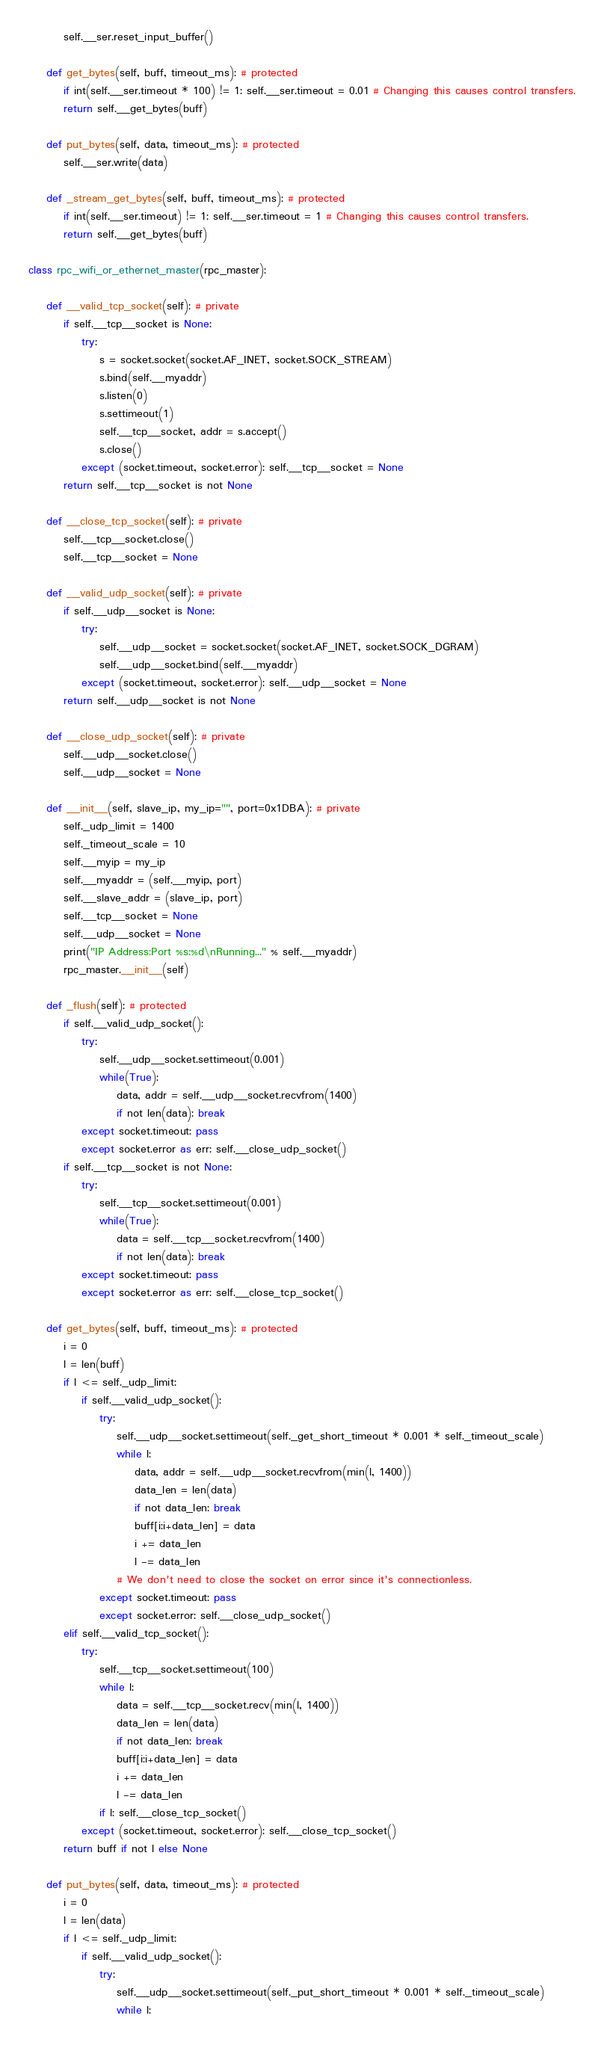<code> <loc_0><loc_0><loc_500><loc_500><_Python_>        self.__ser.reset_input_buffer()

    def get_bytes(self, buff, timeout_ms): # protected
        if int(self.__ser.timeout * 100) != 1: self.__ser.timeout = 0.01 # Changing this causes control transfers.
        return self.__get_bytes(buff)

    def put_bytes(self, data, timeout_ms): # protected
        self.__ser.write(data)

    def _stream_get_bytes(self, buff, timeout_ms): # protected
        if int(self.__ser.timeout) != 1: self.__ser.timeout = 1 # Changing this causes control transfers.
        return self.__get_bytes(buff)

class rpc_wifi_or_ethernet_master(rpc_master):

    def __valid_tcp_socket(self): # private
        if self.__tcp__socket is None:
            try:
                s = socket.socket(socket.AF_INET, socket.SOCK_STREAM)
                s.bind(self.__myaddr)
                s.listen(0)
                s.settimeout(1)
                self.__tcp__socket, addr = s.accept()
                s.close()
            except (socket.timeout, socket.error): self.__tcp__socket = None
        return self.__tcp__socket is not None

    def __close_tcp_socket(self): # private
        self.__tcp__socket.close()
        self.__tcp__socket = None

    def __valid_udp_socket(self): # private
        if self.__udp__socket is None:
            try:
                self.__udp__socket = socket.socket(socket.AF_INET, socket.SOCK_DGRAM)
                self.__udp__socket.bind(self.__myaddr)
            except (socket.timeout, socket.error): self.__udp__socket = None
        return self.__udp__socket is not None

    def __close_udp_socket(self): # private
        self.__udp__socket.close()
        self.__udp__socket = None

    def __init__(self, slave_ip, my_ip="", port=0x1DBA): # private
        self._udp_limit = 1400
        self._timeout_scale = 10
        self.__myip = my_ip
        self.__myaddr = (self.__myip, port)
        self.__slave_addr = (slave_ip, port)
        self.__tcp__socket = None
        self.__udp__socket = None
        print("IP Address:Port %s:%d\nRunning..." % self.__myaddr)
        rpc_master.__init__(self)

    def _flush(self): # protected
        if self.__valid_udp_socket():
            try:
                self.__udp__socket.settimeout(0.001)
                while(True):
                    data, addr = self.__udp__socket.recvfrom(1400)
                    if not len(data): break
            except socket.timeout: pass
            except socket.error as err: self.__close_udp_socket()
        if self.__tcp__socket is not None:
            try:
                self.__tcp__socket.settimeout(0.001)
                while(True):
                    data = self.__tcp__socket.recvfrom(1400)
                    if not len(data): break
            except socket.timeout: pass
            except socket.error as err: self.__close_tcp_socket()

    def get_bytes(self, buff, timeout_ms): # protected
        i = 0
        l = len(buff)
        if l <= self._udp_limit:
            if self.__valid_udp_socket():
                try:
                    self.__udp__socket.settimeout(self._get_short_timeout * 0.001 * self._timeout_scale)
                    while l:
                        data, addr = self.__udp__socket.recvfrom(min(l, 1400))
                        data_len = len(data)
                        if not data_len: break
                        buff[i:i+data_len] = data
                        i += data_len
                        l -= data_len
                    # We don't need to close the socket on error since it's connectionless.
                except socket.timeout: pass
                except socket.error: self.__close_udp_socket()
        elif self.__valid_tcp_socket():
            try:
                self.__tcp__socket.settimeout(100)
                while l:
                    data = self.__tcp__socket.recv(min(l, 1400))
                    data_len = len(data)
                    if not data_len: break
                    buff[i:i+data_len] = data
                    i += data_len
                    l -= data_len
                if l: self.__close_tcp_socket()
            except (socket.timeout, socket.error): self.__close_tcp_socket()
        return buff if not l else None

    def put_bytes(self, data, timeout_ms): # protected
        i = 0
        l = len(data)
        if l <= self._udp_limit:
            if self.__valid_udp_socket():
                try:
                    self.__udp__socket.settimeout(self._put_short_timeout * 0.001 * self._timeout_scale)
                    while l:</code> 